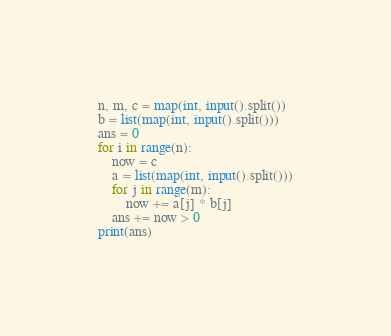Convert code to text. <code><loc_0><loc_0><loc_500><loc_500><_Python_>n, m, c = map(int, input().split())
b = list(map(int, input().split()))
ans = 0
for i in range(n):
    now = c
    a = list(map(int, input().split()))
    for j in range(m):
        now += a[j] * b[j]
    ans += now > 0
print(ans)
</code> 